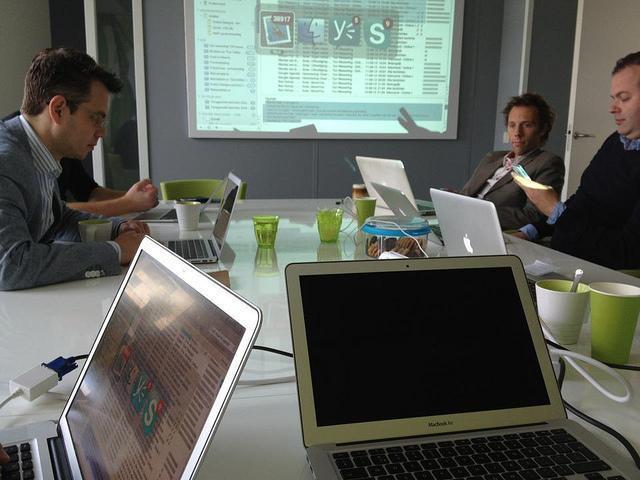How many people are there?
Give a very brief answer. 3. How many laptops can be seen?
Give a very brief answer. 5. How many cups are there?
Give a very brief answer. 2. 